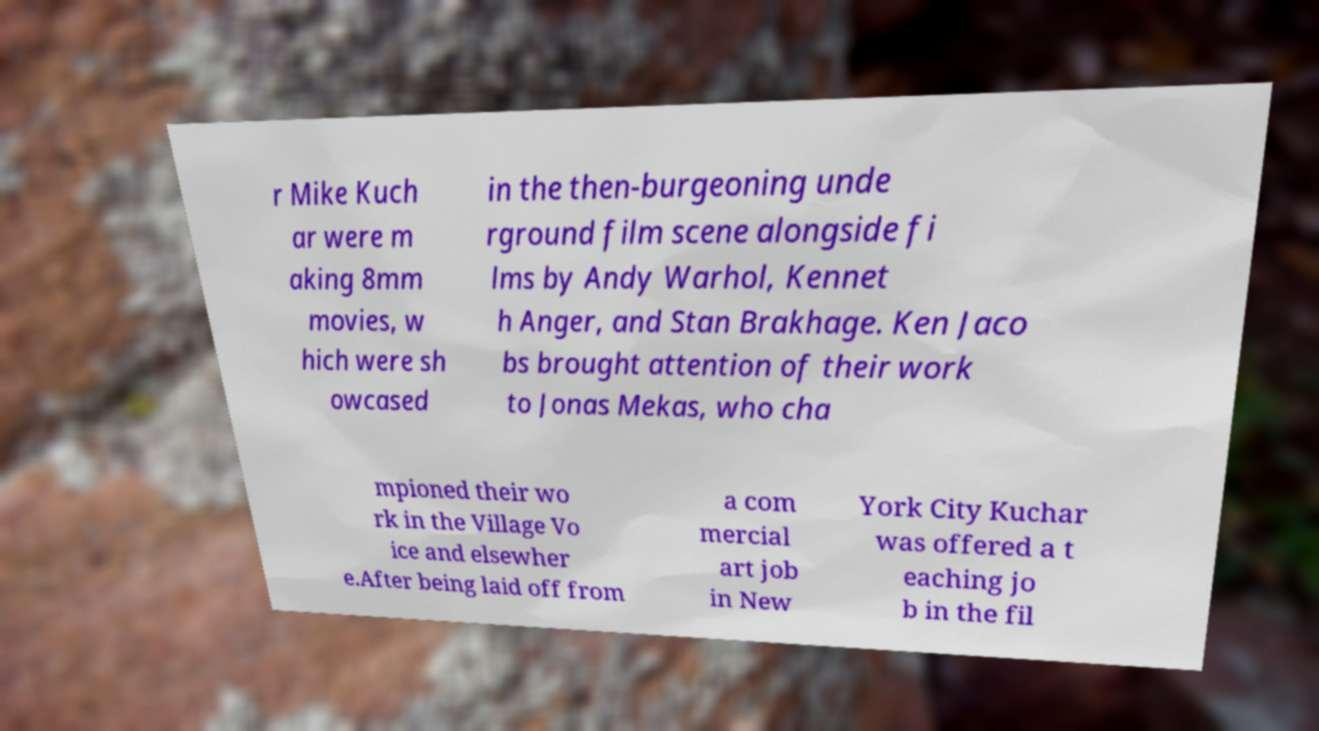Please identify and transcribe the text found in this image. r Mike Kuch ar were m aking 8mm movies, w hich were sh owcased in the then-burgeoning unde rground film scene alongside fi lms by Andy Warhol, Kennet h Anger, and Stan Brakhage. Ken Jaco bs brought attention of their work to Jonas Mekas, who cha mpioned their wo rk in the Village Vo ice and elsewher e.After being laid off from a com mercial art job in New York City Kuchar was offered a t eaching jo b in the fil 